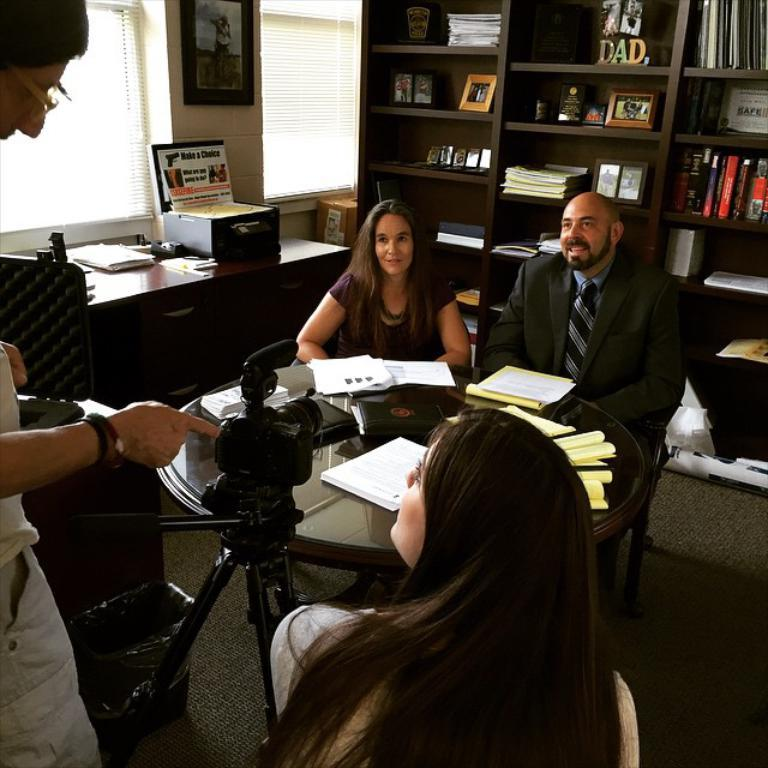Provide a one-sentence caption for the provided image. Group of politician around a table by a sign that says Make a Choice. 